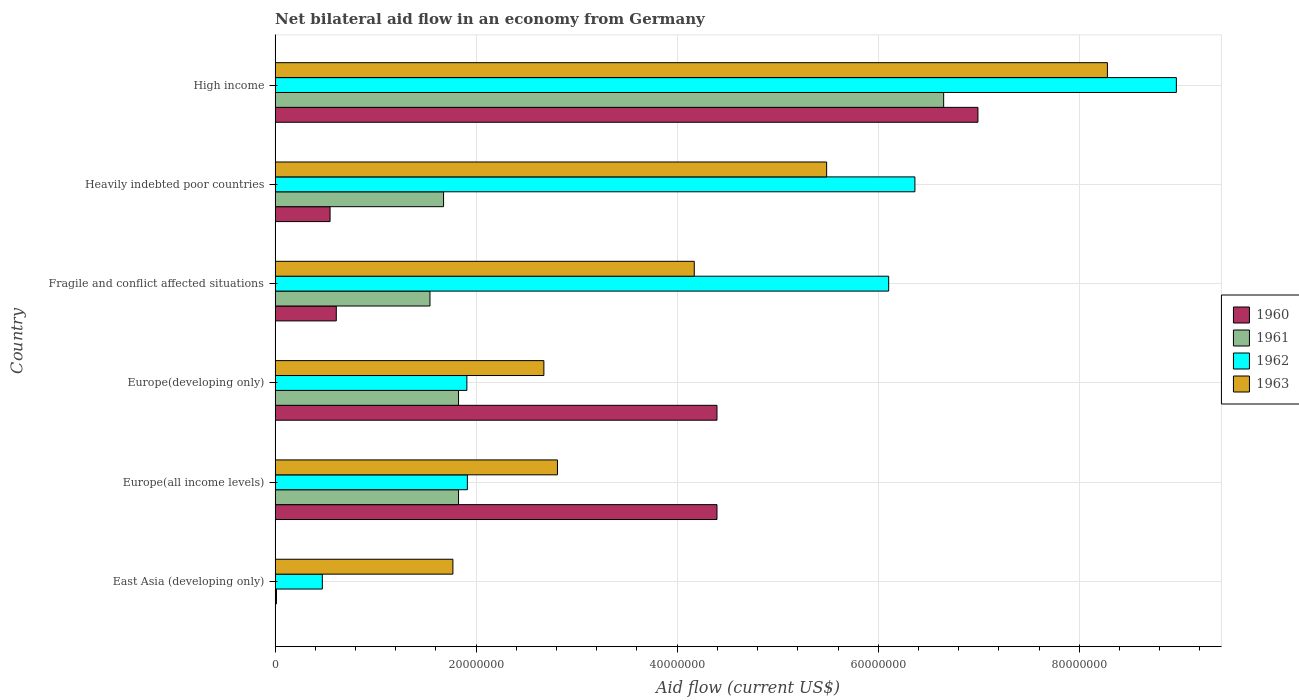Are the number of bars on each tick of the Y-axis equal?
Your answer should be compact. Yes. How many bars are there on the 2nd tick from the bottom?
Give a very brief answer. 4. What is the label of the 3rd group of bars from the top?
Your answer should be very brief. Fragile and conflict affected situations. What is the net bilateral aid flow in 1962 in Heavily indebted poor countries?
Offer a terse response. 6.36e+07. Across all countries, what is the maximum net bilateral aid flow in 1961?
Make the answer very short. 6.65e+07. Across all countries, what is the minimum net bilateral aid flow in 1962?
Provide a short and direct response. 4.70e+06. In which country was the net bilateral aid flow in 1960 maximum?
Keep it short and to the point. High income. In which country was the net bilateral aid flow in 1961 minimum?
Your answer should be very brief. East Asia (developing only). What is the total net bilateral aid flow in 1963 in the graph?
Offer a very short reply. 2.52e+08. What is the difference between the net bilateral aid flow in 1963 in Europe(developing only) and that in Fragile and conflict affected situations?
Make the answer very short. -1.50e+07. What is the difference between the net bilateral aid flow in 1961 in Heavily indebted poor countries and the net bilateral aid flow in 1963 in High income?
Your answer should be very brief. -6.60e+07. What is the average net bilateral aid flow in 1962 per country?
Keep it short and to the point. 4.29e+07. What is the difference between the net bilateral aid flow in 1963 and net bilateral aid flow in 1962 in Heavily indebted poor countries?
Make the answer very short. -8.78e+06. What is the ratio of the net bilateral aid flow in 1960 in Europe(all income levels) to that in Europe(developing only)?
Offer a terse response. 1. What is the difference between the highest and the second highest net bilateral aid flow in 1962?
Make the answer very short. 2.60e+07. What is the difference between the highest and the lowest net bilateral aid flow in 1960?
Your answer should be very brief. 6.99e+07. In how many countries, is the net bilateral aid flow in 1962 greater than the average net bilateral aid flow in 1962 taken over all countries?
Your answer should be very brief. 3. Is the sum of the net bilateral aid flow in 1961 in East Asia (developing only) and High income greater than the maximum net bilateral aid flow in 1960 across all countries?
Your response must be concise. No. Is it the case that in every country, the sum of the net bilateral aid flow in 1961 and net bilateral aid flow in 1963 is greater than the net bilateral aid flow in 1960?
Give a very brief answer. Yes. How many bars are there?
Your response must be concise. 24. Are all the bars in the graph horizontal?
Ensure brevity in your answer.  Yes. How many countries are there in the graph?
Offer a very short reply. 6. What is the difference between two consecutive major ticks on the X-axis?
Ensure brevity in your answer.  2.00e+07. Are the values on the major ticks of X-axis written in scientific E-notation?
Keep it short and to the point. No. How many legend labels are there?
Provide a succinct answer. 4. How are the legend labels stacked?
Keep it short and to the point. Vertical. What is the title of the graph?
Make the answer very short. Net bilateral aid flow in an economy from Germany. Does "2006" appear as one of the legend labels in the graph?
Ensure brevity in your answer.  No. What is the Aid flow (current US$) of 1960 in East Asia (developing only)?
Keep it short and to the point. 3.00e+04. What is the Aid flow (current US$) in 1961 in East Asia (developing only)?
Provide a succinct answer. 1.40e+05. What is the Aid flow (current US$) in 1962 in East Asia (developing only)?
Make the answer very short. 4.70e+06. What is the Aid flow (current US$) of 1963 in East Asia (developing only)?
Give a very brief answer. 1.77e+07. What is the Aid flow (current US$) of 1960 in Europe(all income levels)?
Provide a short and direct response. 4.40e+07. What is the Aid flow (current US$) in 1961 in Europe(all income levels)?
Ensure brevity in your answer.  1.82e+07. What is the Aid flow (current US$) of 1962 in Europe(all income levels)?
Make the answer very short. 1.91e+07. What is the Aid flow (current US$) in 1963 in Europe(all income levels)?
Your answer should be very brief. 2.81e+07. What is the Aid flow (current US$) of 1960 in Europe(developing only)?
Give a very brief answer. 4.40e+07. What is the Aid flow (current US$) in 1961 in Europe(developing only)?
Keep it short and to the point. 1.82e+07. What is the Aid flow (current US$) in 1962 in Europe(developing only)?
Your answer should be very brief. 1.91e+07. What is the Aid flow (current US$) of 1963 in Europe(developing only)?
Offer a terse response. 2.67e+07. What is the Aid flow (current US$) of 1960 in Fragile and conflict affected situations?
Provide a succinct answer. 6.09e+06. What is the Aid flow (current US$) in 1961 in Fragile and conflict affected situations?
Give a very brief answer. 1.54e+07. What is the Aid flow (current US$) of 1962 in Fragile and conflict affected situations?
Ensure brevity in your answer.  6.10e+07. What is the Aid flow (current US$) in 1963 in Fragile and conflict affected situations?
Offer a terse response. 4.17e+07. What is the Aid flow (current US$) of 1960 in Heavily indebted poor countries?
Your answer should be very brief. 5.47e+06. What is the Aid flow (current US$) of 1961 in Heavily indebted poor countries?
Keep it short and to the point. 1.68e+07. What is the Aid flow (current US$) in 1962 in Heavily indebted poor countries?
Provide a short and direct response. 6.36e+07. What is the Aid flow (current US$) of 1963 in Heavily indebted poor countries?
Offer a terse response. 5.49e+07. What is the Aid flow (current US$) in 1960 in High income?
Make the answer very short. 6.99e+07. What is the Aid flow (current US$) of 1961 in High income?
Give a very brief answer. 6.65e+07. What is the Aid flow (current US$) of 1962 in High income?
Offer a terse response. 8.97e+07. What is the Aid flow (current US$) in 1963 in High income?
Offer a very short reply. 8.28e+07. Across all countries, what is the maximum Aid flow (current US$) in 1960?
Offer a very short reply. 6.99e+07. Across all countries, what is the maximum Aid flow (current US$) in 1961?
Ensure brevity in your answer.  6.65e+07. Across all countries, what is the maximum Aid flow (current US$) in 1962?
Your answer should be very brief. 8.97e+07. Across all countries, what is the maximum Aid flow (current US$) in 1963?
Your answer should be very brief. 8.28e+07. Across all countries, what is the minimum Aid flow (current US$) of 1961?
Give a very brief answer. 1.40e+05. Across all countries, what is the minimum Aid flow (current US$) of 1962?
Provide a short and direct response. 4.70e+06. Across all countries, what is the minimum Aid flow (current US$) in 1963?
Provide a succinct answer. 1.77e+07. What is the total Aid flow (current US$) of 1960 in the graph?
Make the answer very short. 1.69e+08. What is the total Aid flow (current US$) in 1961 in the graph?
Give a very brief answer. 1.35e+08. What is the total Aid flow (current US$) in 1962 in the graph?
Offer a very short reply. 2.57e+08. What is the total Aid flow (current US$) of 1963 in the graph?
Provide a short and direct response. 2.52e+08. What is the difference between the Aid flow (current US$) in 1960 in East Asia (developing only) and that in Europe(all income levels)?
Make the answer very short. -4.39e+07. What is the difference between the Aid flow (current US$) of 1961 in East Asia (developing only) and that in Europe(all income levels)?
Your answer should be very brief. -1.81e+07. What is the difference between the Aid flow (current US$) in 1962 in East Asia (developing only) and that in Europe(all income levels)?
Make the answer very short. -1.44e+07. What is the difference between the Aid flow (current US$) of 1963 in East Asia (developing only) and that in Europe(all income levels)?
Provide a succinct answer. -1.04e+07. What is the difference between the Aid flow (current US$) in 1960 in East Asia (developing only) and that in Europe(developing only)?
Your answer should be compact. -4.39e+07. What is the difference between the Aid flow (current US$) in 1961 in East Asia (developing only) and that in Europe(developing only)?
Provide a succinct answer. -1.81e+07. What is the difference between the Aid flow (current US$) in 1962 in East Asia (developing only) and that in Europe(developing only)?
Your answer should be very brief. -1.44e+07. What is the difference between the Aid flow (current US$) of 1963 in East Asia (developing only) and that in Europe(developing only)?
Provide a succinct answer. -9.05e+06. What is the difference between the Aid flow (current US$) of 1960 in East Asia (developing only) and that in Fragile and conflict affected situations?
Keep it short and to the point. -6.06e+06. What is the difference between the Aid flow (current US$) in 1961 in East Asia (developing only) and that in Fragile and conflict affected situations?
Offer a terse response. -1.53e+07. What is the difference between the Aid flow (current US$) in 1962 in East Asia (developing only) and that in Fragile and conflict affected situations?
Make the answer very short. -5.63e+07. What is the difference between the Aid flow (current US$) in 1963 in East Asia (developing only) and that in Fragile and conflict affected situations?
Offer a very short reply. -2.40e+07. What is the difference between the Aid flow (current US$) in 1960 in East Asia (developing only) and that in Heavily indebted poor countries?
Ensure brevity in your answer.  -5.44e+06. What is the difference between the Aid flow (current US$) of 1961 in East Asia (developing only) and that in Heavily indebted poor countries?
Make the answer very short. -1.66e+07. What is the difference between the Aid flow (current US$) in 1962 in East Asia (developing only) and that in Heavily indebted poor countries?
Offer a very short reply. -5.90e+07. What is the difference between the Aid flow (current US$) of 1963 in East Asia (developing only) and that in Heavily indebted poor countries?
Make the answer very short. -3.72e+07. What is the difference between the Aid flow (current US$) in 1960 in East Asia (developing only) and that in High income?
Your answer should be very brief. -6.99e+07. What is the difference between the Aid flow (current US$) in 1961 in East Asia (developing only) and that in High income?
Give a very brief answer. -6.64e+07. What is the difference between the Aid flow (current US$) in 1962 in East Asia (developing only) and that in High income?
Ensure brevity in your answer.  -8.50e+07. What is the difference between the Aid flow (current US$) in 1963 in East Asia (developing only) and that in High income?
Offer a very short reply. -6.51e+07. What is the difference between the Aid flow (current US$) of 1961 in Europe(all income levels) and that in Europe(developing only)?
Offer a terse response. 0. What is the difference between the Aid flow (current US$) in 1962 in Europe(all income levels) and that in Europe(developing only)?
Ensure brevity in your answer.  5.00e+04. What is the difference between the Aid flow (current US$) in 1963 in Europe(all income levels) and that in Europe(developing only)?
Keep it short and to the point. 1.35e+06. What is the difference between the Aid flow (current US$) in 1960 in Europe(all income levels) and that in Fragile and conflict affected situations?
Provide a short and direct response. 3.79e+07. What is the difference between the Aid flow (current US$) of 1961 in Europe(all income levels) and that in Fragile and conflict affected situations?
Your response must be concise. 2.84e+06. What is the difference between the Aid flow (current US$) of 1962 in Europe(all income levels) and that in Fragile and conflict affected situations?
Your answer should be compact. -4.19e+07. What is the difference between the Aid flow (current US$) of 1963 in Europe(all income levels) and that in Fragile and conflict affected situations?
Your response must be concise. -1.36e+07. What is the difference between the Aid flow (current US$) in 1960 in Europe(all income levels) and that in Heavily indebted poor countries?
Ensure brevity in your answer.  3.85e+07. What is the difference between the Aid flow (current US$) in 1961 in Europe(all income levels) and that in Heavily indebted poor countries?
Your answer should be compact. 1.49e+06. What is the difference between the Aid flow (current US$) of 1962 in Europe(all income levels) and that in Heavily indebted poor countries?
Give a very brief answer. -4.45e+07. What is the difference between the Aid flow (current US$) in 1963 in Europe(all income levels) and that in Heavily indebted poor countries?
Give a very brief answer. -2.68e+07. What is the difference between the Aid flow (current US$) of 1960 in Europe(all income levels) and that in High income?
Your answer should be compact. -2.60e+07. What is the difference between the Aid flow (current US$) of 1961 in Europe(all income levels) and that in High income?
Ensure brevity in your answer.  -4.83e+07. What is the difference between the Aid flow (current US$) of 1962 in Europe(all income levels) and that in High income?
Your response must be concise. -7.05e+07. What is the difference between the Aid flow (current US$) in 1963 in Europe(all income levels) and that in High income?
Ensure brevity in your answer.  -5.47e+07. What is the difference between the Aid flow (current US$) in 1960 in Europe(developing only) and that in Fragile and conflict affected situations?
Your answer should be compact. 3.79e+07. What is the difference between the Aid flow (current US$) in 1961 in Europe(developing only) and that in Fragile and conflict affected situations?
Offer a very short reply. 2.84e+06. What is the difference between the Aid flow (current US$) of 1962 in Europe(developing only) and that in Fragile and conflict affected situations?
Ensure brevity in your answer.  -4.20e+07. What is the difference between the Aid flow (current US$) in 1963 in Europe(developing only) and that in Fragile and conflict affected situations?
Your answer should be very brief. -1.50e+07. What is the difference between the Aid flow (current US$) of 1960 in Europe(developing only) and that in Heavily indebted poor countries?
Keep it short and to the point. 3.85e+07. What is the difference between the Aid flow (current US$) of 1961 in Europe(developing only) and that in Heavily indebted poor countries?
Your response must be concise. 1.49e+06. What is the difference between the Aid flow (current US$) in 1962 in Europe(developing only) and that in Heavily indebted poor countries?
Give a very brief answer. -4.46e+07. What is the difference between the Aid flow (current US$) of 1963 in Europe(developing only) and that in Heavily indebted poor countries?
Provide a short and direct response. -2.81e+07. What is the difference between the Aid flow (current US$) of 1960 in Europe(developing only) and that in High income?
Your answer should be very brief. -2.60e+07. What is the difference between the Aid flow (current US$) of 1961 in Europe(developing only) and that in High income?
Make the answer very short. -4.83e+07. What is the difference between the Aid flow (current US$) of 1962 in Europe(developing only) and that in High income?
Your answer should be very brief. -7.06e+07. What is the difference between the Aid flow (current US$) in 1963 in Europe(developing only) and that in High income?
Offer a terse response. -5.61e+07. What is the difference between the Aid flow (current US$) of 1960 in Fragile and conflict affected situations and that in Heavily indebted poor countries?
Give a very brief answer. 6.20e+05. What is the difference between the Aid flow (current US$) of 1961 in Fragile and conflict affected situations and that in Heavily indebted poor countries?
Provide a succinct answer. -1.35e+06. What is the difference between the Aid flow (current US$) in 1962 in Fragile and conflict affected situations and that in Heavily indebted poor countries?
Offer a terse response. -2.61e+06. What is the difference between the Aid flow (current US$) in 1963 in Fragile and conflict affected situations and that in Heavily indebted poor countries?
Your answer should be compact. -1.32e+07. What is the difference between the Aid flow (current US$) of 1960 in Fragile and conflict affected situations and that in High income?
Make the answer very short. -6.38e+07. What is the difference between the Aid flow (current US$) of 1961 in Fragile and conflict affected situations and that in High income?
Keep it short and to the point. -5.11e+07. What is the difference between the Aid flow (current US$) in 1962 in Fragile and conflict affected situations and that in High income?
Provide a short and direct response. -2.86e+07. What is the difference between the Aid flow (current US$) of 1963 in Fragile and conflict affected situations and that in High income?
Provide a succinct answer. -4.11e+07. What is the difference between the Aid flow (current US$) in 1960 in Heavily indebted poor countries and that in High income?
Your answer should be very brief. -6.44e+07. What is the difference between the Aid flow (current US$) of 1961 in Heavily indebted poor countries and that in High income?
Offer a terse response. -4.98e+07. What is the difference between the Aid flow (current US$) of 1962 in Heavily indebted poor countries and that in High income?
Offer a terse response. -2.60e+07. What is the difference between the Aid flow (current US$) of 1963 in Heavily indebted poor countries and that in High income?
Provide a short and direct response. -2.79e+07. What is the difference between the Aid flow (current US$) in 1960 in East Asia (developing only) and the Aid flow (current US$) in 1961 in Europe(all income levels)?
Make the answer very short. -1.82e+07. What is the difference between the Aid flow (current US$) in 1960 in East Asia (developing only) and the Aid flow (current US$) in 1962 in Europe(all income levels)?
Ensure brevity in your answer.  -1.91e+07. What is the difference between the Aid flow (current US$) of 1960 in East Asia (developing only) and the Aid flow (current US$) of 1963 in Europe(all income levels)?
Your answer should be very brief. -2.81e+07. What is the difference between the Aid flow (current US$) of 1961 in East Asia (developing only) and the Aid flow (current US$) of 1962 in Europe(all income levels)?
Your answer should be very brief. -1.90e+07. What is the difference between the Aid flow (current US$) of 1961 in East Asia (developing only) and the Aid flow (current US$) of 1963 in Europe(all income levels)?
Your answer should be compact. -2.80e+07. What is the difference between the Aid flow (current US$) in 1962 in East Asia (developing only) and the Aid flow (current US$) in 1963 in Europe(all income levels)?
Offer a terse response. -2.34e+07. What is the difference between the Aid flow (current US$) in 1960 in East Asia (developing only) and the Aid flow (current US$) in 1961 in Europe(developing only)?
Your answer should be compact. -1.82e+07. What is the difference between the Aid flow (current US$) in 1960 in East Asia (developing only) and the Aid flow (current US$) in 1962 in Europe(developing only)?
Ensure brevity in your answer.  -1.90e+07. What is the difference between the Aid flow (current US$) of 1960 in East Asia (developing only) and the Aid flow (current US$) of 1963 in Europe(developing only)?
Your answer should be very brief. -2.67e+07. What is the difference between the Aid flow (current US$) in 1961 in East Asia (developing only) and the Aid flow (current US$) in 1962 in Europe(developing only)?
Offer a very short reply. -1.89e+07. What is the difference between the Aid flow (current US$) in 1961 in East Asia (developing only) and the Aid flow (current US$) in 1963 in Europe(developing only)?
Make the answer very short. -2.66e+07. What is the difference between the Aid flow (current US$) in 1962 in East Asia (developing only) and the Aid flow (current US$) in 1963 in Europe(developing only)?
Ensure brevity in your answer.  -2.20e+07. What is the difference between the Aid flow (current US$) of 1960 in East Asia (developing only) and the Aid flow (current US$) of 1961 in Fragile and conflict affected situations?
Make the answer very short. -1.54e+07. What is the difference between the Aid flow (current US$) of 1960 in East Asia (developing only) and the Aid flow (current US$) of 1962 in Fragile and conflict affected situations?
Your answer should be compact. -6.10e+07. What is the difference between the Aid flow (current US$) in 1960 in East Asia (developing only) and the Aid flow (current US$) in 1963 in Fragile and conflict affected situations?
Provide a succinct answer. -4.17e+07. What is the difference between the Aid flow (current US$) in 1961 in East Asia (developing only) and the Aid flow (current US$) in 1962 in Fragile and conflict affected situations?
Ensure brevity in your answer.  -6.09e+07. What is the difference between the Aid flow (current US$) in 1961 in East Asia (developing only) and the Aid flow (current US$) in 1963 in Fragile and conflict affected situations?
Your answer should be compact. -4.16e+07. What is the difference between the Aid flow (current US$) in 1962 in East Asia (developing only) and the Aid flow (current US$) in 1963 in Fragile and conflict affected situations?
Provide a succinct answer. -3.70e+07. What is the difference between the Aid flow (current US$) of 1960 in East Asia (developing only) and the Aid flow (current US$) of 1961 in Heavily indebted poor countries?
Your answer should be compact. -1.67e+07. What is the difference between the Aid flow (current US$) in 1960 in East Asia (developing only) and the Aid flow (current US$) in 1962 in Heavily indebted poor countries?
Make the answer very short. -6.36e+07. What is the difference between the Aid flow (current US$) in 1960 in East Asia (developing only) and the Aid flow (current US$) in 1963 in Heavily indebted poor countries?
Your answer should be very brief. -5.48e+07. What is the difference between the Aid flow (current US$) in 1961 in East Asia (developing only) and the Aid flow (current US$) in 1962 in Heavily indebted poor countries?
Ensure brevity in your answer.  -6.35e+07. What is the difference between the Aid flow (current US$) of 1961 in East Asia (developing only) and the Aid flow (current US$) of 1963 in Heavily indebted poor countries?
Offer a terse response. -5.47e+07. What is the difference between the Aid flow (current US$) in 1962 in East Asia (developing only) and the Aid flow (current US$) in 1963 in Heavily indebted poor countries?
Your answer should be very brief. -5.02e+07. What is the difference between the Aid flow (current US$) in 1960 in East Asia (developing only) and the Aid flow (current US$) in 1961 in High income?
Your answer should be very brief. -6.65e+07. What is the difference between the Aid flow (current US$) in 1960 in East Asia (developing only) and the Aid flow (current US$) in 1962 in High income?
Your answer should be very brief. -8.96e+07. What is the difference between the Aid flow (current US$) in 1960 in East Asia (developing only) and the Aid flow (current US$) in 1963 in High income?
Provide a succinct answer. -8.28e+07. What is the difference between the Aid flow (current US$) of 1961 in East Asia (developing only) and the Aid flow (current US$) of 1962 in High income?
Your answer should be compact. -8.95e+07. What is the difference between the Aid flow (current US$) of 1961 in East Asia (developing only) and the Aid flow (current US$) of 1963 in High income?
Provide a short and direct response. -8.27e+07. What is the difference between the Aid flow (current US$) of 1962 in East Asia (developing only) and the Aid flow (current US$) of 1963 in High income?
Your answer should be very brief. -7.81e+07. What is the difference between the Aid flow (current US$) of 1960 in Europe(all income levels) and the Aid flow (current US$) of 1961 in Europe(developing only)?
Give a very brief answer. 2.57e+07. What is the difference between the Aid flow (current US$) in 1960 in Europe(all income levels) and the Aid flow (current US$) in 1962 in Europe(developing only)?
Give a very brief answer. 2.49e+07. What is the difference between the Aid flow (current US$) of 1960 in Europe(all income levels) and the Aid flow (current US$) of 1963 in Europe(developing only)?
Keep it short and to the point. 1.72e+07. What is the difference between the Aid flow (current US$) in 1961 in Europe(all income levels) and the Aid flow (current US$) in 1962 in Europe(developing only)?
Make the answer very short. -8.30e+05. What is the difference between the Aid flow (current US$) of 1961 in Europe(all income levels) and the Aid flow (current US$) of 1963 in Europe(developing only)?
Give a very brief answer. -8.49e+06. What is the difference between the Aid flow (current US$) in 1962 in Europe(all income levels) and the Aid flow (current US$) in 1963 in Europe(developing only)?
Provide a succinct answer. -7.61e+06. What is the difference between the Aid flow (current US$) in 1960 in Europe(all income levels) and the Aid flow (current US$) in 1961 in Fragile and conflict affected situations?
Offer a very short reply. 2.86e+07. What is the difference between the Aid flow (current US$) of 1960 in Europe(all income levels) and the Aid flow (current US$) of 1962 in Fragile and conflict affected situations?
Offer a very short reply. -1.71e+07. What is the difference between the Aid flow (current US$) in 1960 in Europe(all income levels) and the Aid flow (current US$) in 1963 in Fragile and conflict affected situations?
Your answer should be compact. 2.26e+06. What is the difference between the Aid flow (current US$) in 1961 in Europe(all income levels) and the Aid flow (current US$) in 1962 in Fragile and conflict affected situations?
Your response must be concise. -4.28e+07. What is the difference between the Aid flow (current US$) of 1961 in Europe(all income levels) and the Aid flow (current US$) of 1963 in Fragile and conflict affected situations?
Offer a terse response. -2.34e+07. What is the difference between the Aid flow (current US$) of 1962 in Europe(all income levels) and the Aid flow (current US$) of 1963 in Fragile and conflict affected situations?
Your response must be concise. -2.26e+07. What is the difference between the Aid flow (current US$) in 1960 in Europe(all income levels) and the Aid flow (current US$) in 1961 in Heavily indebted poor countries?
Offer a terse response. 2.72e+07. What is the difference between the Aid flow (current US$) of 1960 in Europe(all income levels) and the Aid flow (current US$) of 1962 in Heavily indebted poor countries?
Provide a succinct answer. -1.97e+07. What is the difference between the Aid flow (current US$) of 1960 in Europe(all income levels) and the Aid flow (current US$) of 1963 in Heavily indebted poor countries?
Make the answer very short. -1.09e+07. What is the difference between the Aid flow (current US$) in 1961 in Europe(all income levels) and the Aid flow (current US$) in 1962 in Heavily indebted poor countries?
Your response must be concise. -4.54e+07. What is the difference between the Aid flow (current US$) of 1961 in Europe(all income levels) and the Aid flow (current US$) of 1963 in Heavily indebted poor countries?
Your response must be concise. -3.66e+07. What is the difference between the Aid flow (current US$) of 1962 in Europe(all income levels) and the Aid flow (current US$) of 1963 in Heavily indebted poor countries?
Provide a short and direct response. -3.57e+07. What is the difference between the Aid flow (current US$) in 1960 in Europe(all income levels) and the Aid flow (current US$) in 1961 in High income?
Provide a succinct answer. -2.26e+07. What is the difference between the Aid flow (current US$) in 1960 in Europe(all income levels) and the Aid flow (current US$) in 1962 in High income?
Provide a short and direct response. -4.57e+07. What is the difference between the Aid flow (current US$) in 1960 in Europe(all income levels) and the Aid flow (current US$) in 1963 in High income?
Offer a terse response. -3.88e+07. What is the difference between the Aid flow (current US$) of 1961 in Europe(all income levels) and the Aid flow (current US$) of 1962 in High income?
Provide a succinct answer. -7.14e+07. What is the difference between the Aid flow (current US$) in 1961 in Europe(all income levels) and the Aid flow (current US$) in 1963 in High income?
Give a very brief answer. -6.46e+07. What is the difference between the Aid flow (current US$) of 1962 in Europe(all income levels) and the Aid flow (current US$) of 1963 in High income?
Provide a short and direct response. -6.37e+07. What is the difference between the Aid flow (current US$) in 1960 in Europe(developing only) and the Aid flow (current US$) in 1961 in Fragile and conflict affected situations?
Offer a terse response. 2.86e+07. What is the difference between the Aid flow (current US$) in 1960 in Europe(developing only) and the Aid flow (current US$) in 1962 in Fragile and conflict affected situations?
Your answer should be very brief. -1.71e+07. What is the difference between the Aid flow (current US$) of 1960 in Europe(developing only) and the Aid flow (current US$) of 1963 in Fragile and conflict affected situations?
Offer a terse response. 2.26e+06. What is the difference between the Aid flow (current US$) of 1961 in Europe(developing only) and the Aid flow (current US$) of 1962 in Fragile and conflict affected situations?
Provide a succinct answer. -4.28e+07. What is the difference between the Aid flow (current US$) of 1961 in Europe(developing only) and the Aid flow (current US$) of 1963 in Fragile and conflict affected situations?
Give a very brief answer. -2.34e+07. What is the difference between the Aid flow (current US$) of 1962 in Europe(developing only) and the Aid flow (current US$) of 1963 in Fragile and conflict affected situations?
Your answer should be very brief. -2.26e+07. What is the difference between the Aid flow (current US$) of 1960 in Europe(developing only) and the Aid flow (current US$) of 1961 in Heavily indebted poor countries?
Your answer should be compact. 2.72e+07. What is the difference between the Aid flow (current US$) in 1960 in Europe(developing only) and the Aid flow (current US$) in 1962 in Heavily indebted poor countries?
Offer a very short reply. -1.97e+07. What is the difference between the Aid flow (current US$) of 1960 in Europe(developing only) and the Aid flow (current US$) of 1963 in Heavily indebted poor countries?
Ensure brevity in your answer.  -1.09e+07. What is the difference between the Aid flow (current US$) of 1961 in Europe(developing only) and the Aid flow (current US$) of 1962 in Heavily indebted poor countries?
Offer a very short reply. -4.54e+07. What is the difference between the Aid flow (current US$) in 1961 in Europe(developing only) and the Aid flow (current US$) in 1963 in Heavily indebted poor countries?
Provide a succinct answer. -3.66e+07. What is the difference between the Aid flow (current US$) of 1962 in Europe(developing only) and the Aid flow (current US$) of 1963 in Heavily indebted poor countries?
Offer a terse response. -3.58e+07. What is the difference between the Aid flow (current US$) of 1960 in Europe(developing only) and the Aid flow (current US$) of 1961 in High income?
Offer a terse response. -2.26e+07. What is the difference between the Aid flow (current US$) in 1960 in Europe(developing only) and the Aid flow (current US$) in 1962 in High income?
Ensure brevity in your answer.  -4.57e+07. What is the difference between the Aid flow (current US$) in 1960 in Europe(developing only) and the Aid flow (current US$) in 1963 in High income?
Offer a terse response. -3.88e+07. What is the difference between the Aid flow (current US$) of 1961 in Europe(developing only) and the Aid flow (current US$) of 1962 in High income?
Provide a succinct answer. -7.14e+07. What is the difference between the Aid flow (current US$) in 1961 in Europe(developing only) and the Aid flow (current US$) in 1963 in High income?
Your answer should be very brief. -6.46e+07. What is the difference between the Aid flow (current US$) of 1962 in Europe(developing only) and the Aid flow (current US$) of 1963 in High income?
Offer a terse response. -6.37e+07. What is the difference between the Aid flow (current US$) of 1960 in Fragile and conflict affected situations and the Aid flow (current US$) of 1961 in Heavily indebted poor countries?
Provide a short and direct response. -1.07e+07. What is the difference between the Aid flow (current US$) of 1960 in Fragile and conflict affected situations and the Aid flow (current US$) of 1962 in Heavily indebted poor countries?
Your answer should be compact. -5.76e+07. What is the difference between the Aid flow (current US$) in 1960 in Fragile and conflict affected situations and the Aid flow (current US$) in 1963 in Heavily indebted poor countries?
Offer a very short reply. -4.88e+07. What is the difference between the Aid flow (current US$) in 1961 in Fragile and conflict affected situations and the Aid flow (current US$) in 1962 in Heavily indebted poor countries?
Give a very brief answer. -4.82e+07. What is the difference between the Aid flow (current US$) in 1961 in Fragile and conflict affected situations and the Aid flow (current US$) in 1963 in Heavily indebted poor countries?
Ensure brevity in your answer.  -3.95e+07. What is the difference between the Aid flow (current US$) in 1962 in Fragile and conflict affected situations and the Aid flow (current US$) in 1963 in Heavily indebted poor countries?
Give a very brief answer. 6.17e+06. What is the difference between the Aid flow (current US$) in 1960 in Fragile and conflict affected situations and the Aid flow (current US$) in 1961 in High income?
Keep it short and to the point. -6.04e+07. What is the difference between the Aid flow (current US$) of 1960 in Fragile and conflict affected situations and the Aid flow (current US$) of 1962 in High income?
Your answer should be compact. -8.36e+07. What is the difference between the Aid flow (current US$) of 1960 in Fragile and conflict affected situations and the Aid flow (current US$) of 1963 in High income?
Provide a short and direct response. -7.67e+07. What is the difference between the Aid flow (current US$) of 1961 in Fragile and conflict affected situations and the Aid flow (current US$) of 1962 in High income?
Offer a terse response. -7.42e+07. What is the difference between the Aid flow (current US$) in 1961 in Fragile and conflict affected situations and the Aid flow (current US$) in 1963 in High income?
Your answer should be very brief. -6.74e+07. What is the difference between the Aid flow (current US$) of 1962 in Fragile and conflict affected situations and the Aid flow (current US$) of 1963 in High income?
Provide a short and direct response. -2.18e+07. What is the difference between the Aid flow (current US$) of 1960 in Heavily indebted poor countries and the Aid flow (current US$) of 1961 in High income?
Provide a succinct answer. -6.10e+07. What is the difference between the Aid flow (current US$) in 1960 in Heavily indebted poor countries and the Aid flow (current US$) in 1962 in High income?
Your response must be concise. -8.42e+07. What is the difference between the Aid flow (current US$) in 1960 in Heavily indebted poor countries and the Aid flow (current US$) in 1963 in High income?
Give a very brief answer. -7.73e+07. What is the difference between the Aid flow (current US$) in 1961 in Heavily indebted poor countries and the Aid flow (current US$) in 1962 in High income?
Your answer should be compact. -7.29e+07. What is the difference between the Aid flow (current US$) of 1961 in Heavily indebted poor countries and the Aid flow (current US$) of 1963 in High income?
Keep it short and to the point. -6.60e+07. What is the difference between the Aid flow (current US$) of 1962 in Heavily indebted poor countries and the Aid flow (current US$) of 1963 in High income?
Provide a succinct answer. -1.92e+07. What is the average Aid flow (current US$) of 1960 per country?
Keep it short and to the point. 2.82e+07. What is the average Aid flow (current US$) in 1961 per country?
Provide a succinct answer. 2.26e+07. What is the average Aid flow (current US$) of 1962 per country?
Offer a terse response. 4.29e+07. What is the average Aid flow (current US$) in 1963 per country?
Your answer should be very brief. 4.20e+07. What is the difference between the Aid flow (current US$) of 1960 and Aid flow (current US$) of 1962 in East Asia (developing only)?
Give a very brief answer. -4.67e+06. What is the difference between the Aid flow (current US$) of 1960 and Aid flow (current US$) of 1963 in East Asia (developing only)?
Offer a very short reply. -1.77e+07. What is the difference between the Aid flow (current US$) in 1961 and Aid flow (current US$) in 1962 in East Asia (developing only)?
Give a very brief answer. -4.56e+06. What is the difference between the Aid flow (current US$) of 1961 and Aid flow (current US$) of 1963 in East Asia (developing only)?
Offer a very short reply. -1.76e+07. What is the difference between the Aid flow (current US$) of 1962 and Aid flow (current US$) of 1963 in East Asia (developing only)?
Your answer should be very brief. -1.30e+07. What is the difference between the Aid flow (current US$) in 1960 and Aid flow (current US$) in 1961 in Europe(all income levels)?
Provide a succinct answer. 2.57e+07. What is the difference between the Aid flow (current US$) in 1960 and Aid flow (current US$) in 1962 in Europe(all income levels)?
Give a very brief answer. 2.48e+07. What is the difference between the Aid flow (current US$) in 1960 and Aid flow (current US$) in 1963 in Europe(all income levels)?
Offer a terse response. 1.59e+07. What is the difference between the Aid flow (current US$) in 1961 and Aid flow (current US$) in 1962 in Europe(all income levels)?
Make the answer very short. -8.80e+05. What is the difference between the Aid flow (current US$) in 1961 and Aid flow (current US$) in 1963 in Europe(all income levels)?
Provide a short and direct response. -9.84e+06. What is the difference between the Aid flow (current US$) of 1962 and Aid flow (current US$) of 1963 in Europe(all income levels)?
Your answer should be compact. -8.96e+06. What is the difference between the Aid flow (current US$) in 1960 and Aid flow (current US$) in 1961 in Europe(developing only)?
Ensure brevity in your answer.  2.57e+07. What is the difference between the Aid flow (current US$) of 1960 and Aid flow (current US$) of 1962 in Europe(developing only)?
Your response must be concise. 2.49e+07. What is the difference between the Aid flow (current US$) in 1960 and Aid flow (current US$) in 1963 in Europe(developing only)?
Your answer should be very brief. 1.72e+07. What is the difference between the Aid flow (current US$) in 1961 and Aid flow (current US$) in 1962 in Europe(developing only)?
Give a very brief answer. -8.30e+05. What is the difference between the Aid flow (current US$) of 1961 and Aid flow (current US$) of 1963 in Europe(developing only)?
Ensure brevity in your answer.  -8.49e+06. What is the difference between the Aid flow (current US$) in 1962 and Aid flow (current US$) in 1963 in Europe(developing only)?
Ensure brevity in your answer.  -7.66e+06. What is the difference between the Aid flow (current US$) in 1960 and Aid flow (current US$) in 1961 in Fragile and conflict affected situations?
Give a very brief answer. -9.32e+06. What is the difference between the Aid flow (current US$) in 1960 and Aid flow (current US$) in 1962 in Fragile and conflict affected situations?
Offer a very short reply. -5.50e+07. What is the difference between the Aid flow (current US$) in 1960 and Aid flow (current US$) in 1963 in Fragile and conflict affected situations?
Provide a succinct answer. -3.56e+07. What is the difference between the Aid flow (current US$) of 1961 and Aid flow (current US$) of 1962 in Fragile and conflict affected situations?
Provide a short and direct response. -4.56e+07. What is the difference between the Aid flow (current US$) of 1961 and Aid flow (current US$) of 1963 in Fragile and conflict affected situations?
Your response must be concise. -2.63e+07. What is the difference between the Aid flow (current US$) in 1962 and Aid flow (current US$) in 1963 in Fragile and conflict affected situations?
Provide a succinct answer. 1.93e+07. What is the difference between the Aid flow (current US$) in 1960 and Aid flow (current US$) in 1961 in Heavily indebted poor countries?
Offer a very short reply. -1.13e+07. What is the difference between the Aid flow (current US$) in 1960 and Aid flow (current US$) in 1962 in Heavily indebted poor countries?
Offer a very short reply. -5.82e+07. What is the difference between the Aid flow (current US$) in 1960 and Aid flow (current US$) in 1963 in Heavily indebted poor countries?
Offer a very short reply. -4.94e+07. What is the difference between the Aid flow (current US$) of 1961 and Aid flow (current US$) of 1962 in Heavily indebted poor countries?
Offer a very short reply. -4.69e+07. What is the difference between the Aid flow (current US$) of 1961 and Aid flow (current US$) of 1963 in Heavily indebted poor countries?
Your answer should be very brief. -3.81e+07. What is the difference between the Aid flow (current US$) in 1962 and Aid flow (current US$) in 1963 in Heavily indebted poor countries?
Offer a very short reply. 8.78e+06. What is the difference between the Aid flow (current US$) in 1960 and Aid flow (current US$) in 1961 in High income?
Provide a succinct answer. 3.41e+06. What is the difference between the Aid flow (current US$) of 1960 and Aid flow (current US$) of 1962 in High income?
Your answer should be compact. -1.97e+07. What is the difference between the Aid flow (current US$) in 1960 and Aid flow (current US$) in 1963 in High income?
Your answer should be compact. -1.29e+07. What is the difference between the Aid flow (current US$) of 1961 and Aid flow (current US$) of 1962 in High income?
Your answer should be very brief. -2.32e+07. What is the difference between the Aid flow (current US$) of 1961 and Aid flow (current US$) of 1963 in High income?
Offer a very short reply. -1.63e+07. What is the difference between the Aid flow (current US$) of 1962 and Aid flow (current US$) of 1963 in High income?
Give a very brief answer. 6.86e+06. What is the ratio of the Aid flow (current US$) in 1960 in East Asia (developing only) to that in Europe(all income levels)?
Give a very brief answer. 0. What is the ratio of the Aid flow (current US$) of 1961 in East Asia (developing only) to that in Europe(all income levels)?
Ensure brevity in your answer.  0.01. What is the ratio of the Aid flow (current US$) of 1962 in East Asia (developing only) to that in Europe(all income levels)?
Provide a short and direct response. 0.25. What is the ratio of the Aid flow (current US$) in 1963 in East Asia (developing only) to that in Europe(all income levels)?
Keep it short and to the point. 0.63. What is the ratio of the Aid flow (current US$) in 1960 in East Asia (developing only) to that in Europe(developing only)?
Your response must be concise. 0. What is the ratio of the Aid flow (current US$) in 1961 in East Asia (developing only) to that in Europe(developing only)?
Offer a terse response. 0.01. What is the ratio of the Aid flow (current US$) of 1962 in East Asia (developing only) to that in Europe(developing only)?
Your answer should be very brief. 0.25. What is the ratio of the Aid flow (current US$) in 1963 in East Asia (developing only) to that in Europe(developing only)?
Ensure brevity in your answer.  0.66. What is the ratio of the Aid flow (current US$) in 1960 in East Asia (developing only) to that in Fragile and conflict affected situations?
Keep it short and to the point. 0. What is the ratio of the Aid flow (current US$) of 1961 in East Asia (developing only) to that in Fragile and conflict affected situations?
Provide a succinct answer. 0.01. What is the ratio of the Aid flow (current US$) in 1962 in East Asia (developing only) to that in Fragile and conflict affected situations?
Offer a very short reply. 0.08. What is the ratio of the Aid flow (current US$) in 1963 in East Asia (developing only) to that in Fragile and conflict affected situations?
Your answer should be compact. 0.42. What is the ratio of the Aid flow (current US$) of 1960 in East Asia (developing only) to that in Heavily indebted poor countries?
Offer a very short reply. 0.01. What is the ratio of the Aid flow (current US$) of 1961 in East Asia (developing only) to that in Heavily indebted poor countries?
Offer a terse response. 0.01. What is the ratio of the Aid flow (current US$) in 1962 in East Asia (developing only) to that in Heavily indebted poor countries?
Your answer should be compact. 0.07. What is the ratio of the Aid flow (current US$) in 1963 in East Asia (developing only) to that in Heavily indebted poor countries?
Ensure brevity in your answer.  0.32. What is the ratio of the Aid flow (current US$) of 1961 in East Asia (developing only) to that in High income?
Offer a very short reply. 0. What is the ratio of the Aid flow (current US$) in 1962 in East Asia (developing only) to that in High income?
Make the answer very short. 0.05. What is the ratio of the Aid flow (current US$) of 1963 in East Asia (developing only) to that in High income?
Keep it short and to the point. 0.21. What is the ratio of the Aid flow (current US$) of 1963 in Europe(all income levels) to that in Europe(developing only)?
Your answer should be compact. 1.05. What is the ratio of the Aid flow (current US$) of 1960 in Europe(all income levels) to that in Fragile and conflict affected situations?
Make the answer very short. 7.22. What is the ratio of the Aid flow (current US$) in 1961 in Europe(all income levels) to that in Fragile and conflict affected situations?
Keep it short and to the point. 1.18. What is the ratio of the Aid flow (current US$) in 1962 in Europe(all income levels) to that in Fragile and conflict affected situations?
Give a very brief answer. 0.31. What is the ratio of the Aid flow (current US$) of 1963 in Europe(all income levels) to that in Fragile and conflict affected situations?
Make the answer very short. 0.67. What is the ratio of the Aid flow (current US$) of 1960 in Europe(all income levels) to that in Heavily indebted poor countries?
Provide a succinct answer. 8.04. What is the ratio of the Aid flow (current US$) of 1961 in Europe(all income levels) to that in Heavily indebted poor countries?
Your response must be concise. 1.09. What is the ratio of the Aid flow (current US$) in 1962 in Europe(all income levels) to that in Heavily indebted poor countries?
Give a very brief answer. 0.3. What is the ratio of the Aid flow (current US$) in 1963 in Europe(all income levels) to that in Heavily indebted poor countries?
Give a very brief answer. 0.51. What is the ratio of the Aid flow (current US$) in 1960 in Europe(all income levels) to that in High income?
Your answer should be compact. 0.63. What is the ratio of the Aid flow (current US$) of 1961 in Europe(all income levels) to that in High income?
Your answer should be compact. 0.27. What is the ratio of the Aid flow (current US$) of 1962 in Europe(all income levels) to that in High income?
Your answer should be very brief. 0.21. What is the ratio of the Aid flow (current US$) of 1963 in Europe(all income levels) to that in High income?
Provide a succinct answer. 0.34. What is the ratio of the Aid flow (current US$) in 1960 in Europe(developing only) to that in Fragile and conflict affected situations?
Your response must be concise. 7.22. What is the ratio of the Aid flow (current US$) in 1961 in Europe(developing only) to that in Fragile and conflict affected situations?
Ensure brevity in your answer.  1.18. What is the ratio of the Aid flow (current US$) in 1962 in Europe(developing only) to that in Fragile and conflict affected situations?
Ensure brevity in your answer.  0.31. What is the ratio of the Aid flow (current US$) in 1963 in Europe(developing only) to that in Fragile and conflict affected situations?
Keep it short and to the point. 0.64. What is the ratio of the Aid flow (current US$) of 1960 in Europe(developing only) to that in Heavily indebted poor countries?
Your answer should be very brief. 8.04. What is the ratio of the Aid flow (current US$) of 1961 in Europe(developing only) to that in Heavily indebted poor countries?
Your response must be concise. 1.09. What is the ratio of the Aid flow (current US$) of 1962 in Europe(developing only) to that in Heavily indebted poor countries?
Keep it short and to the point. 0.3. What is the ratio of the Aid flow (current US$) in 1963 in Europe(developing only) to that in Heavily indebted poor countries?
Offer a very short reply. 0.49. What is the ratio of the Aid flow (current US$) in 1960 in Europe(developing only) to that in High income?
Your answer should be compact. 0.63. What is the ratio of the Aid flow (current US$) of 1961 in Europe(developing only) to that in High income?
Your answer should be very brief. 0.27. What is the ratio of the Aid flow (current US$) of 1962 in Europe(developing only) to that in High income?
Provide a short and direct response. 0.21. What is the ratio of the Aid flow (current US$) of 1963 in Europe(developing only) to that in High income?
Make the answer very short. 0.32. What is the ratio of the Aid flow (current US$) of 1960 in Fragile and conflict affected situations to that in Heavily indebted poor countries?
Give a very brief answer. 1.11. What is the ratio of the Aid flow (current US$) of 1961 in Fragile and conflict affected situations to that in Heavily indebted poor countries?
Ensure brevity in your answer.  0.92. What is the ratio of the Aid flow (current US$) in 1963 in Fragile and conflict affected situations to that in Heavily indebted poor countries?
Your answer should be compact. 0.76. What is the ratio of the Aid flow (current US$) of 1960 in Fragile and conflict affected situations to that in High income?
Ensure brevity in your answer.  0.09. What is the ratio of the Aid flow (current US$) in 1961 in Fragile and conflict affected situations to that in High income?
Give a very brief answer. 0.23. What is the ratio of the Aid flow (current US$) in 1962 in Fragile and conflict affected situations to that in High income?
Keep it short and to the point. 0.68. What is the ratio of the Aid flow (current US$) in 1963 in Fragile and conflict affected situations to that in High income?
Give a very brief answer. 0.5. What is the ratio of the Aid flow (current US$) in 1960 in Heavily indebted poor countries to that in High income?
Keep it short and to the point. 0.08. What is the ratio of the Aid flow (current US$) of 1961 in Heavily indebted poor countries to that in High income?
Your answer should be very brief. 0.25. What is the ratio of the Aid flow (current US$) in 1962 in Heavily indebted poor countries to that in High income?
Offer a terse response. 0.71. What is the ratio of the Aid flow (current US$) in 1963 in Heavily indebted poor countries to that in High income?
Your answer should be compact. 0.66. What is the difference between the highest and the second highest Aid flow (current US$) in 1960?
Make the answer very short. 2.60e+07. What is the difference between the highest and the second highest Aid flow (current US$) in 1961?
Provide a succinct answer. 4.83e+07. What is the difference between the highest and the second highest Aid flow (current US$) in 1962?
Give a very brief answer. 2.60e+07. What is the difference between the highest and the second highest Aid flow (current US$) of 1963?
Ensure brevity in your answer.  2.79e+07. What is the difference between the highest and the lowest Aid flow (current US$) in 1960?
Offer a terse response. 6.99e+07. What is the difference between the highest and the lowest Aid flow (current US$) in 1961?
Your answer should be compact. 6.64e+07. What is the difference between the highest and the lowest Aid flow (current US$) in 1962?
Your answer should be very brief. 8.50e+07. What is the difference between the highest and the lowest Aid flow (current US$) of 1963?
Provide a short and direct response. 6.51e+07. 